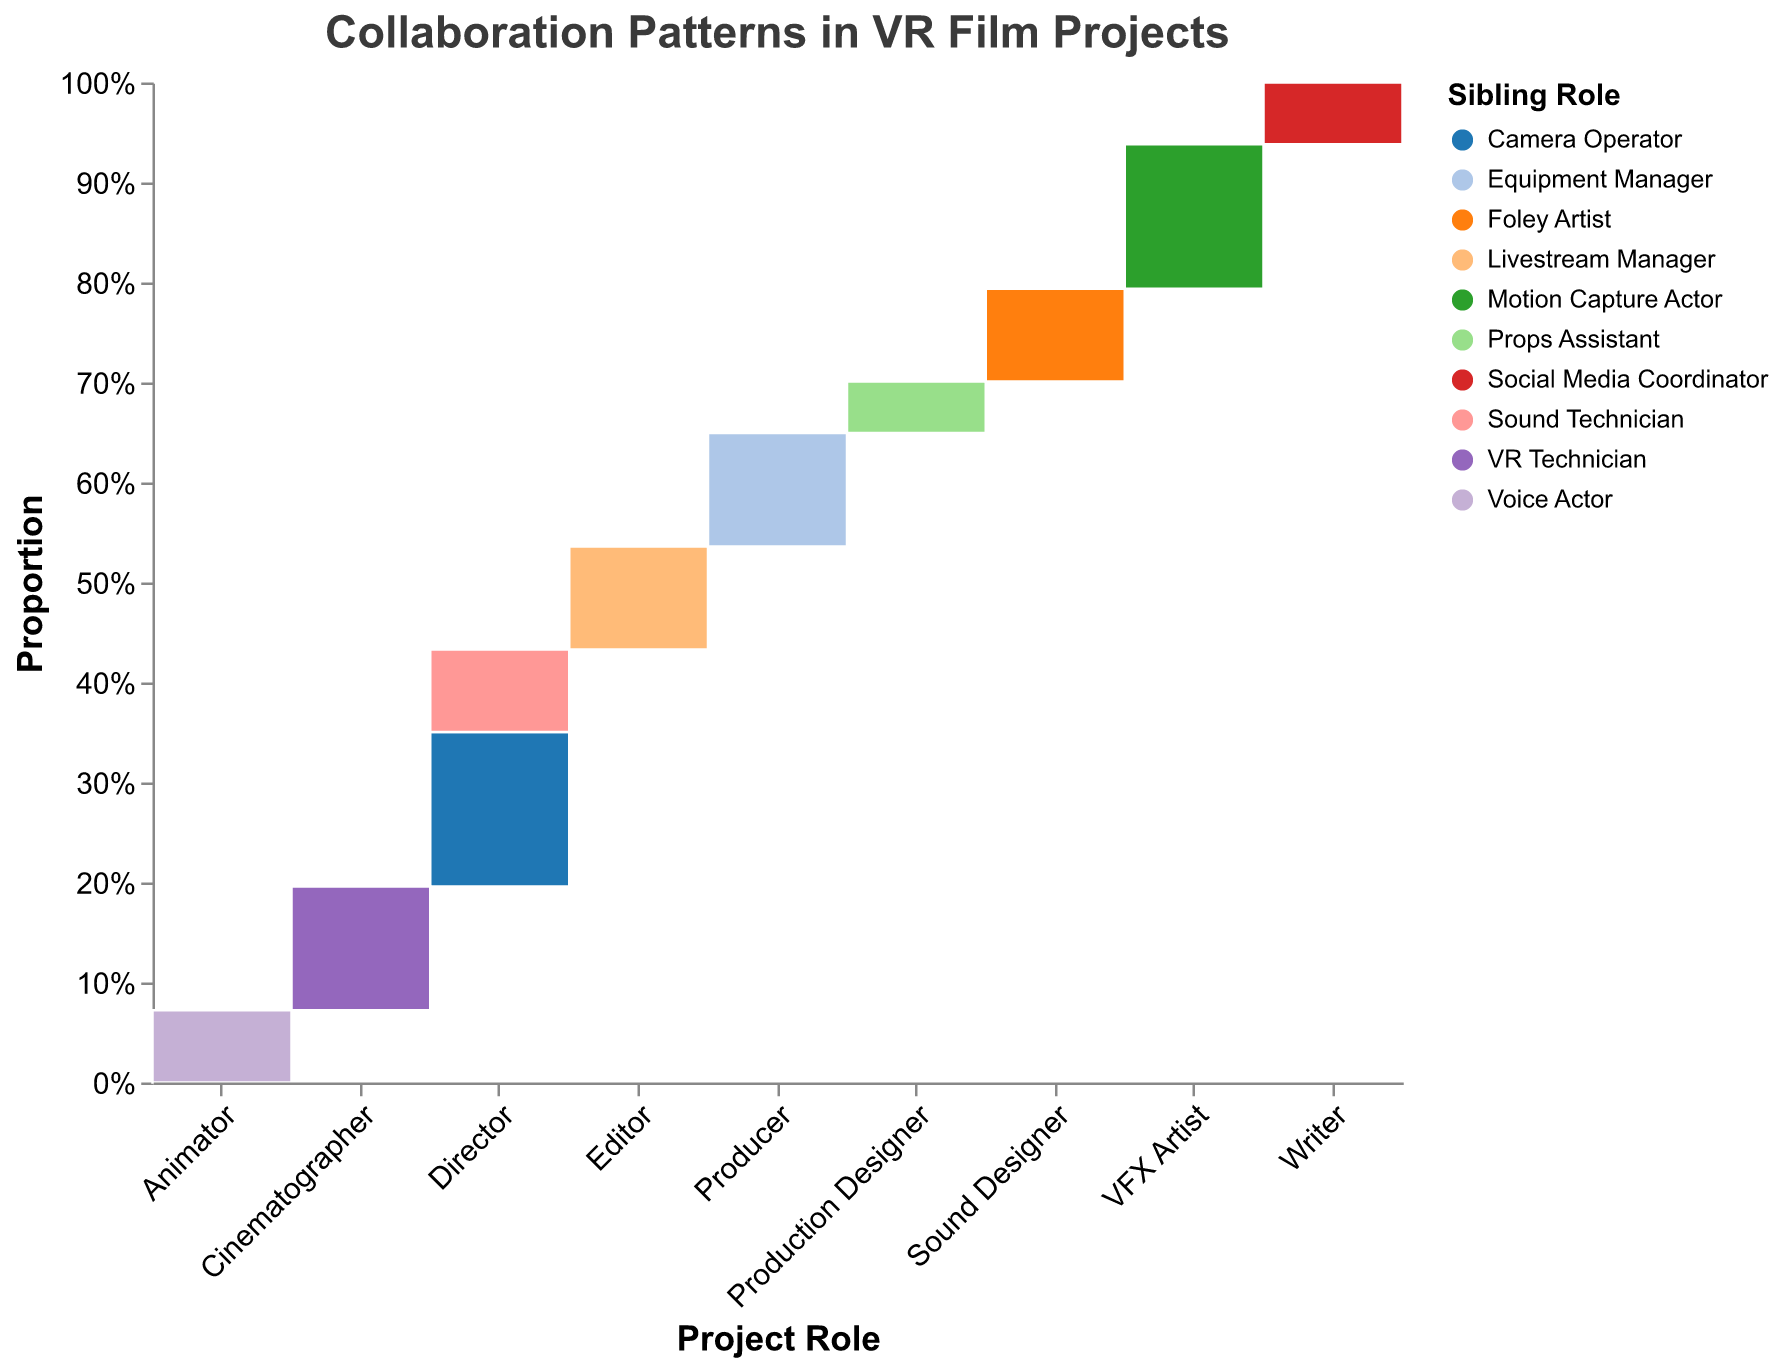What is the title of the figure? The title of the figure is typically found at the top of the chart. It describes the overall content of the plot, which helps viewers understand what the data represents.
Answer: Collaboration Patterns in VR Film Projects Which project role has the highest frequency of collaborations? By examining the figure, you can see the project role with the widest bars (indicating higher frequencies).
Answer: Director Which sibling role has the highest time commitment with the VFX Artist? Look for the color representing the sibling role associated with the "VFX Artist" project role and labeled "High" in the plot.
Answer: Motion Capture Actor What is the most common time commitment level for collaborations involving the Editor? Identify the time commitment labels within the "Editor" role segments and find which is most frequent.
Answer: Medium Compare the time commitment levels for the Producer and Writer project roles. Who has more high time commitments? Look at the segments for "Producer" and "Writer" and count the occurrences of high time commitments within their respective bars.
Answer: Producer How does the collaboration frequency between Directors and Camera Operators compare to Directors and Sound Technicians? Compare the widths of the sections corresponding to these collaborations under the "Director" category.
Answer: Camera Operators collaboration is more frequent What sibling role is associated with the lowest frequency in collaborations? Look for the smallest segment in the plot regardless of the project role.
Answer: Props Assistant Is the collaboration between Animators and Voice Actors higher than that of Writers and Social Media Coordinators? Compare the segment sizes of "Animator - Voice Actor" and "Writer - Social Media Coordinator".
Answer: Yes Which sibling role has the most balanced time commitment across different project roles? Identify a sibling role that appears across different project roles with varying but balanced time commitments.
Answer: Equipment Manager Which project role has the fewest medium time commitments? Examine the plot; find the project role with the smallest or no section labeled "Medium".
Answer: Production Designer 